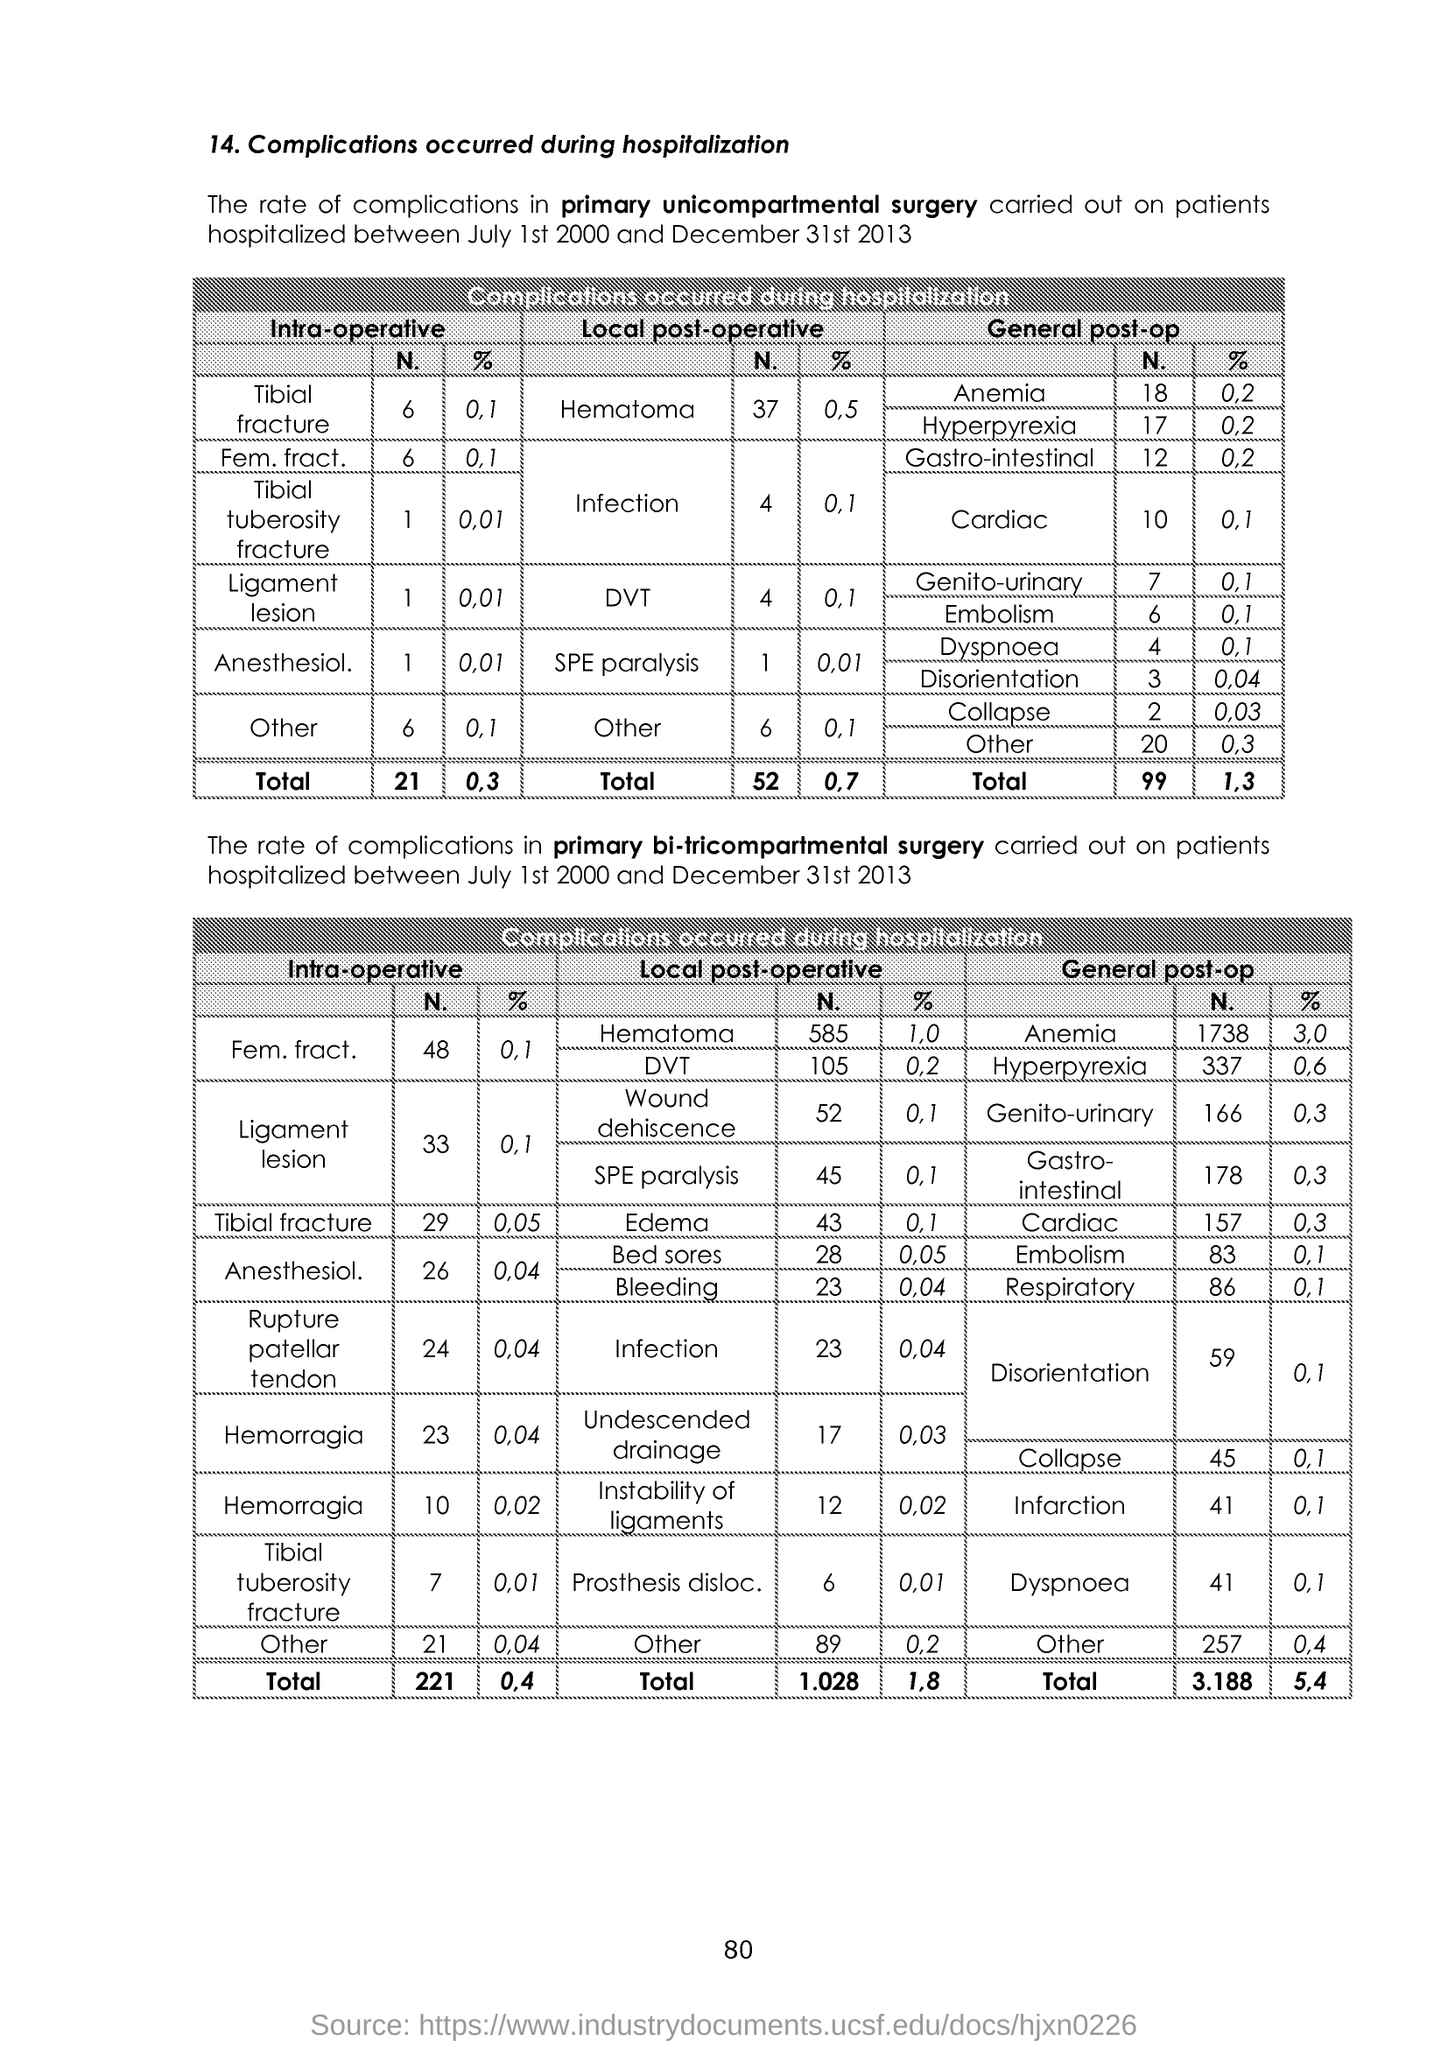Mention a couple of crucial points in this snapshot. The study aims to investigate the anesthesiology intra-operative management in primary unicompartmental surgery, specifically looking at the percentage of patients who experience complications, with a focus on the percentage that occur intra-operatively. The study will examine the impact of various factors on the number of complications, including the type of anesthesia, the patient's age and health status, and the duration of the surgical procedure. The results of this study may provide valuable insights into optimal anesthesiology practices during primary unicompartmental surgery and may lead to improved patient outcomes. The two tables provide information regarding complications that occurred during hospitalization, including the number of patients affected and the types of complications that occurred. 